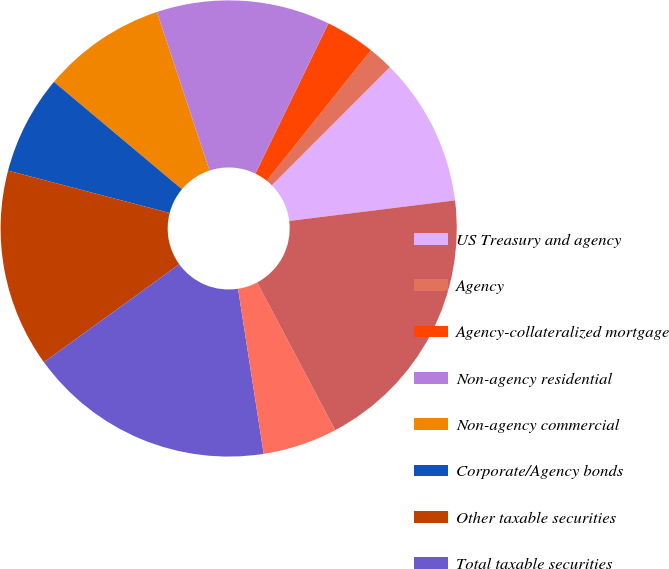Convert chart to OTSL. <chart><loc_0><loc_0><loc_500><loc_500><pie_chart><fcel>US Treasury and agency<fcel>Agency<fcel>Agency-collateralized mortgage<fcel>Non-agency residential<fcel>Non-agency commercial<fcel>Corporate/Agency bonds<fcel>Other taxable securities<fcel>Total taxable securities<fcel>Tax-exempt securities<fcel>Total amortized cost of AFS<nl><fcel>10.54%<fcel>1.77%<fcel>3.52%<fcel>12.3%<fcel>8.79%<fcel>7.03%<fcel>14.05%<fcel>17.48%<fcel>5.28%<fcel>19.23%<nl></chart> 